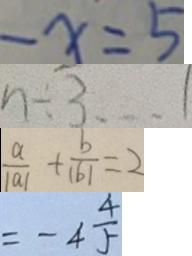<formula> <loc_0><loc_0><loc_500><loc_500>- x = 5 
 n \div 3 \dot s 1 
 \frac { a } { \vert a \vert } + \frac { b } { \vert b \vert } = 2 
 = - 4 \frac { 4 } { 5 }</formula> 